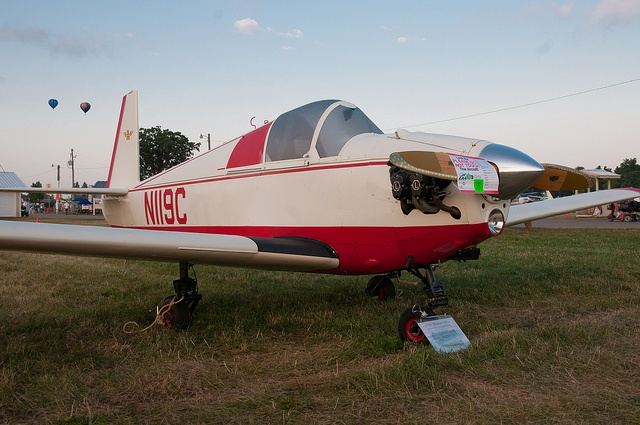Describe the objects in this image and their specific colors. I can see a airplane in darkgray, black, and maroon tones in this image. 